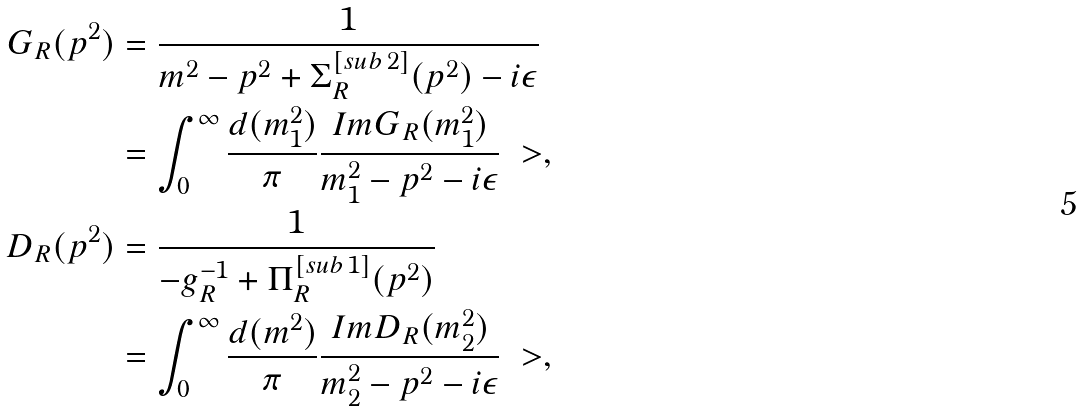<formula> <loc_0><loc_0><loc_500><loc_500>G _ { R } ( p ^ { 2 } ) & = \frac { 1 } { m ^ { 2 } - p ^ { 2 } + \Sigma _ { R } ^ { [ s u b \, 2 ] } ( p ^ { 2 } ) - i \epsilon } \\ & = \int _ { 0 } ^ { \infty } \frac { d ( m _ { 1 } ^ { 2 } ) } { \pi } \frac { I m G _ { R } ( m _ { 1 } ^ { 2 } ) } { m _ { 1 } ^ { 2 } - p ^ { 2 } - i \epsilon } \ > , \\ D _ { R } ( p ^ { 2 } ) & = \frac { 1 } { - g _ { R } ^ { - 1 } + \Pi _ { R } ^ { [ s u b \, 1 ] } ( p ^ { 2 } ) } \\ & = \int _ { 0 } ^ { \infty } \frac { d ( m ^ { 2 } ) } { \pi } \frac { I m D _ { R } ( m _ { 2 } ^ { 2 } ) } { m _ { 2 } ^ { 2 } - p ^ { 2 } - i \epsilon } \ > ,</formula> 